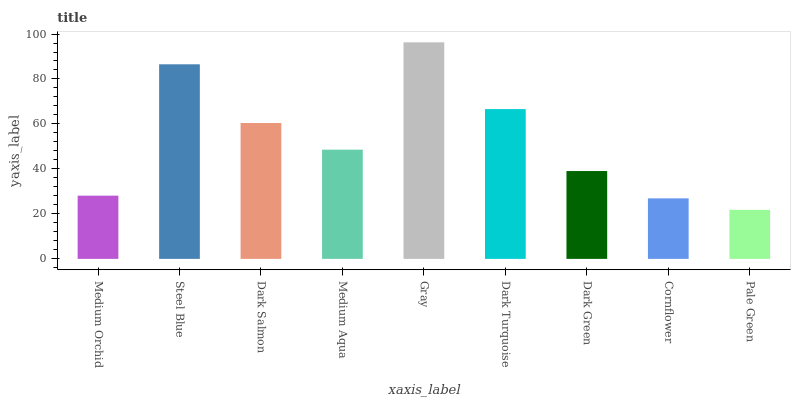Is Pale Green the minimum?
Answer yes or no. Yes. Is Gray the maximum?
Answer yes or no. Yes. Is Steel Blue the minimum?
Answer yes or no. No. Is Steel Blue the maximum?
Answer yes or no. No. Is Steel Blue greater than Medium Orchid?
Answer yes or no. Yes. Is Medium Orchid less than Steel Blue?
Answer yes or no. Yes. Is Medium Orchid greater than Steel Blue?
Answer yes or no. No. Is Steel Blue less than Medium Orchid?
Answer yes or no. No. Is Medium Aqua the high median?
Answer yes or no. Yes. Is Medium Aqua the low median?
Answer yes or no. Yes. Is Gray the high median?
Answer yes or no. No. Is Dark Turquoise the low median?
Answer yes or no. No. 